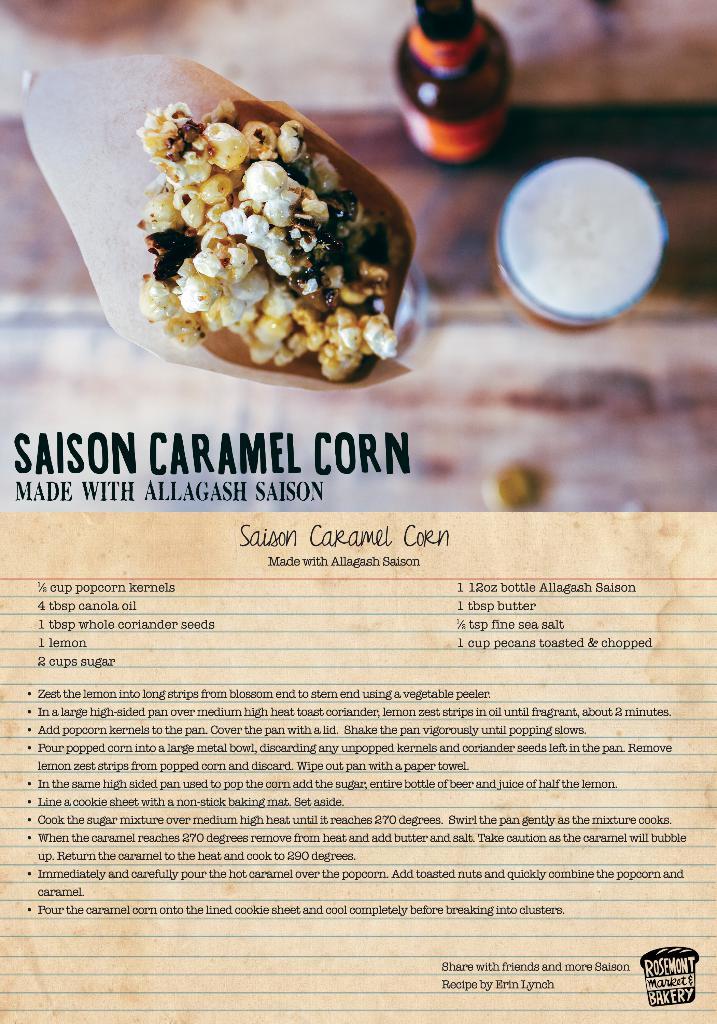What is the name of this recipe?
Provide a succinct answer. Saison caramel corn. Does this recipe include caramel?
Give a very brief answer. Yes. 